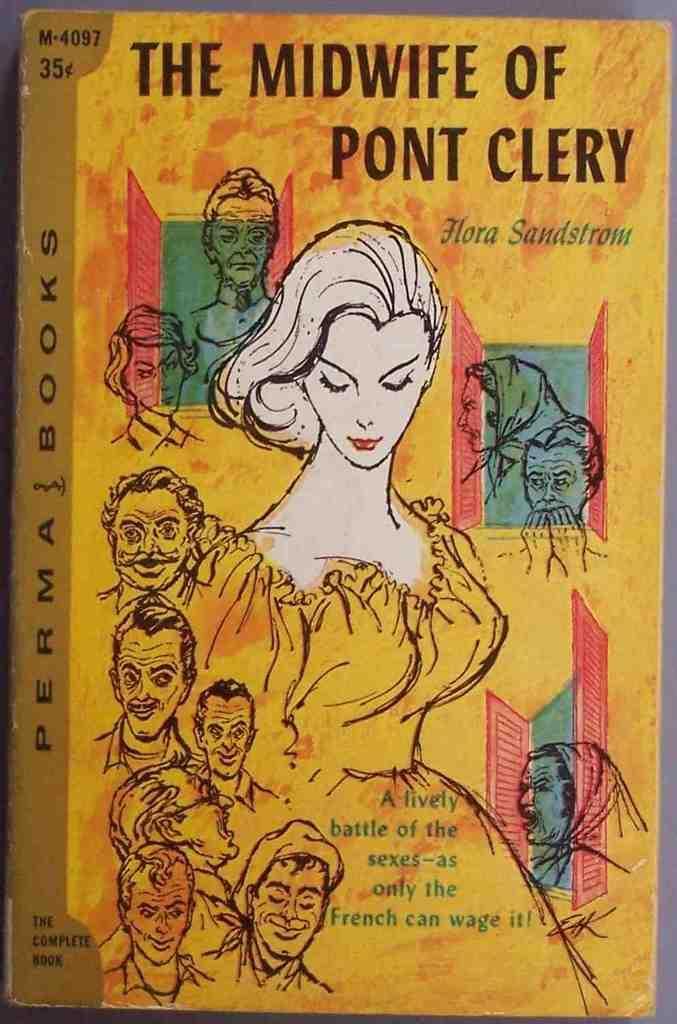Describe this image in one or two sentences. This is a picture of a cover page of book as we can see there are some drawing image of some persons in the middle and there is some text at the top of this image and on the left side of this image. 